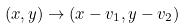Convert formula to latex. <formula><loc_0><loc_0><loc_500><loc_500>( x , y ) \to ( x - v _ { 1 } , y - v _ { 2 } )</formula> 